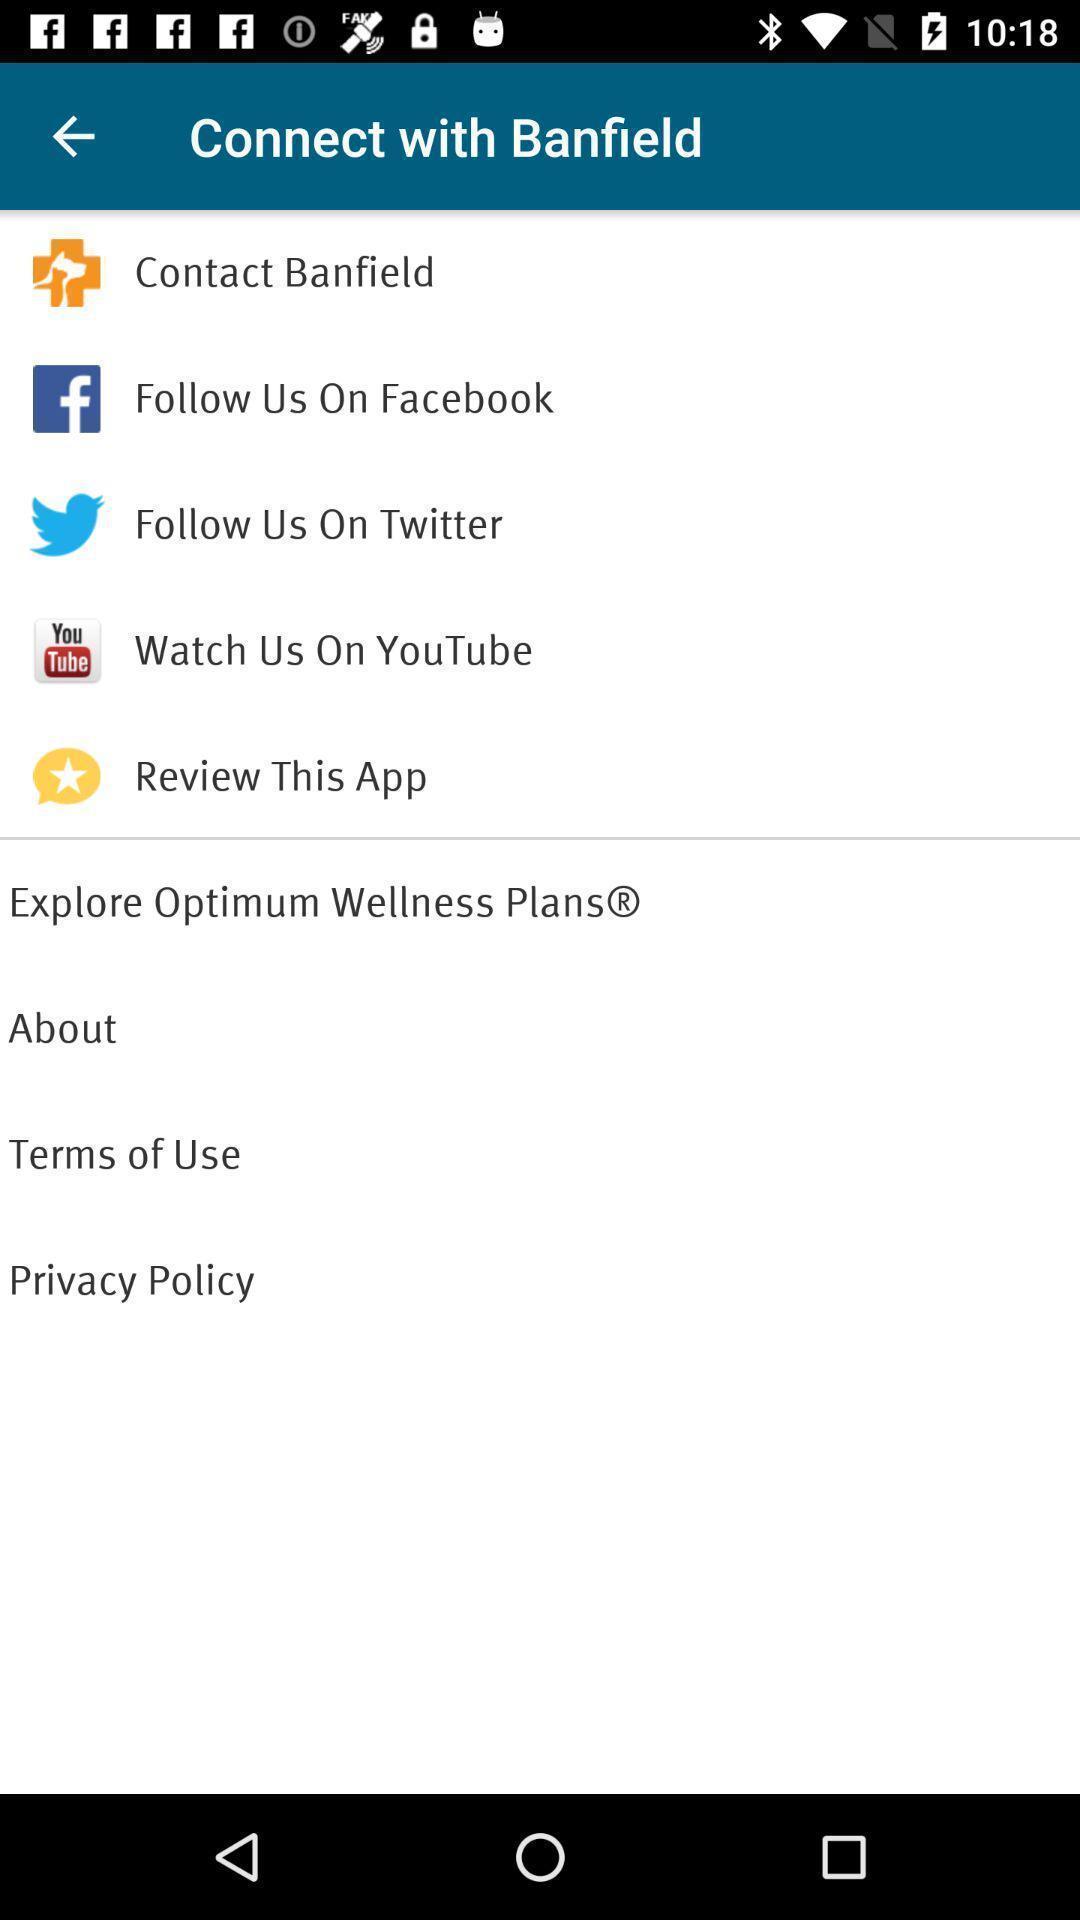Give me a summary of this screen capture. Screen displaying multiple options in a wellness application. 